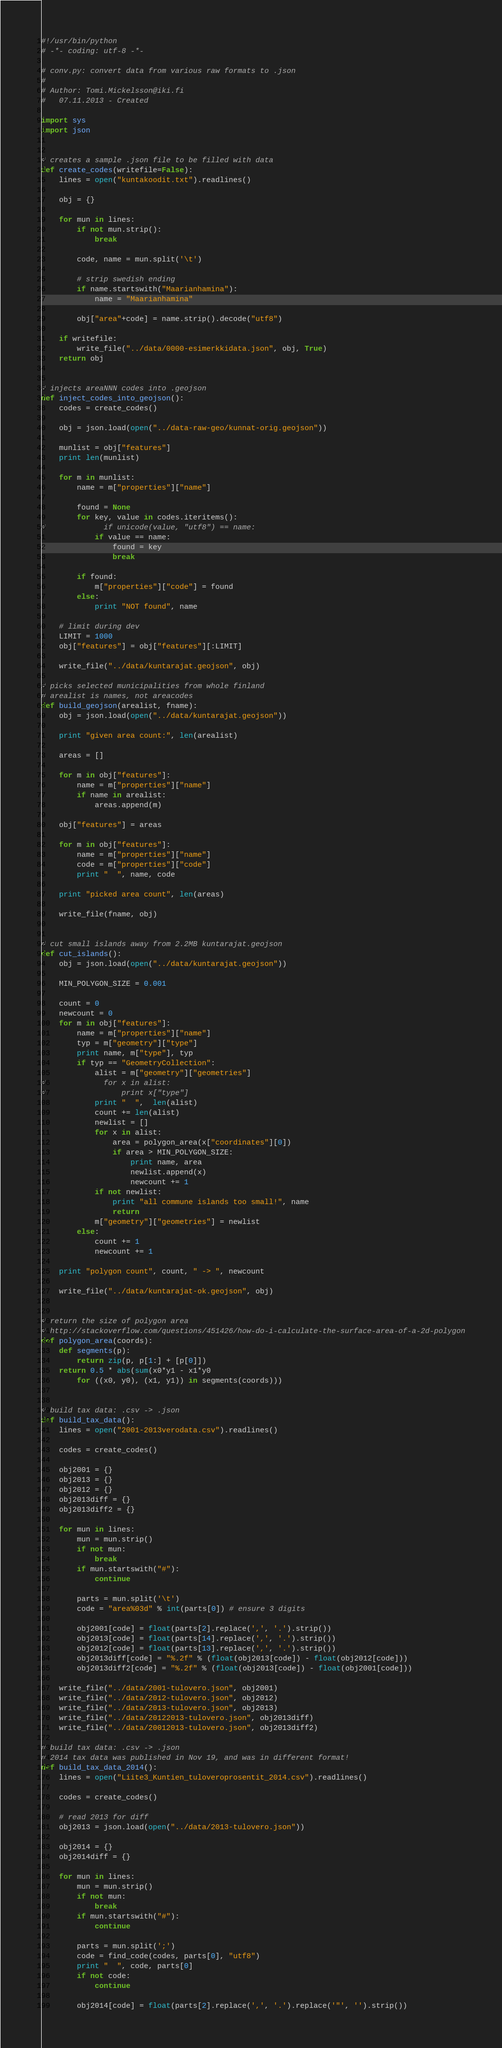Convert code to text. <code><loc_0><loc_0><loc_500><loc_500><_Python_>#!/usr/bin/python
# -*- coding: utf-8 -*-

# conv.py: convert data from various raw formats to .json
#
# Author: Tomi.Mickelsson@iki.fi
#   07.11.2013 - Created

import sys
import json


# creates a sample .json file to be filled with data
def create_codes(writefile=False):
    lines = open("kuntakoodit.txt").readlines()

    obj = {}

    for mun in lines:
        if not mun.strip():
            break

        code, name = mun.split('\t')

        # strip swedish ending
        if name.startswith("Maarianhamina"):
            name = "Maarianhamina"

        obj["area"+code] = name.strip().decode("utf8")

    if writefile:
        write_file("../data/0000-esimerkkidata.json", obj, True)
    return obj


# injects areaNNN codes into .geojson
def inject_codes_into_geojson():
    codes = create_codes()

    obj = json.load(open("../data-raw-geo/kunnat-orig.geojson"))

    munlist = obj["features"]
    print len(munlist)

    for m in munlist:
        name = m["properties"]["name"]

        found = None
        for key, value in codes.iteritems():
#             if unicode(value, "utf8") == name:
            if value == name:
                found = key
                break

        if found:
            m["properties"]["code"] = found
        else:
            print "NOT found", name

    # limit during dev
    LIMIT = 1000
    obj["features"] = obj["features"][:LIMIT]

    write_file("../data/kuntarajat.geojson", obj)

# picks selected municipalities from whole finland
# arealist is names, not areacodes
def build_geojson(arealist, fname):
    obj = json.load(open("../data/kuntarajat.geojson"))

    print "given area count:", len(arealist)

    areas = []

    for m in obj["features"]:
        name = m["properties"]["name"]
        if name in arealist:
            areas.append(m)

    obj["features"] = areas

    for m in obj["features"]:
        name = m["properties"]["name"]
        code = m["properties"]["code"]
        print "  ", name, code

    print "picked area count", len(areas)

    write_file(fname, obj)


# cut small islands away from 2.2MB kuntarajat.geojson
def cut_islands():
    obj = json.load(open("../data/kuntarajat.geojson"))

    MIN_POLYGON_SIZE = 0.001

    count = 0
    newcount = 0
    for m in obj["features"]:
        name = m["properties"]["name"]
        typ = m["geometry"]["type"]
        print name, m["type"], typ
        if typ == "GeometryCollection":
            alist = m["geometry"]["geometries"]
#             for x in alist:
#                 print x["type"]
            print "  ",  len(alist)
            count += len(alist)
            newlist = []
            for x in alist:
                area = polygon_area(x["coordinates"][0])
                if area > MIN_POLYGON_SIZE:
                    print name, area
                    newlist.append(x)
                    newcount += 1
            if not newlist:
                print "all commune islands too small!", name
                return
            m["geometry"]["geometries"] = newlist
        else:
            count += 1
            newcount += 1

    print "polygon count", count, " -> ", newcount

    write_file("../data/kuntarajat-ok.geojson", obj)


# return the size of polygon area
# http://stackoverflow.com/questions/451426/how-do-i-calculate-the-surface-area-of-a-2d-polygon
def polygon_area(coords):
    def segments(p):
        return zip(p, p[1:] + [p[0]])
    return 0.5 * abs(sum(x0*y1 - x1*y0
        for ((x0, y0), (x1, y1)) in segments(coords)))


# build tax data: .csv -> .json
def build_tax_data():
    lines = open("2001-2013verodata.csv").readlines()

    codes = create_codes()

    obj2001 = {}
    obj2013 = {}
    obj2012 = {}
    obj2013diff = {}
    obj2013diff2 = {}

    for mun in lines:
        mun = mun.strip()
        if not mun:
            break
        if mun.startswith("#"):
            continue

        parts = mun.split('\t')
        code = "area%03d" % int(parts[0]) # ensure 3 digits

        obj2001[code] = float(parts[2].replace(',', '.').strip())
        obj2013[code] = float(parts[14].replace(',', '.').strip())
        obj2012[code] = float(parts[13].replace(',', '.').strip())
        obj2013diff[code] = "%.2f" % (float(obj2013[code]) - float(obj2012[code]))
        obj2013diff2[code] = "%.2f" % (float(obj2013[code]) - float(obj2001[code]))

    write_file("../data/2001-tulovero.json", obj2001)
    write_file("../data/2012-tulovero.json", obj2012)
    write_file("../data/2013-tulovero.json", obj2013)
    write_file("../data/20122013-tulovero.json", obj2013diff)
    write_file("../data/20012013-tulovero.json", obj2013diff2)

# build tax data: .csv -> .json
# 2014 tax data was published in Nov 19, and was in different format!
def build_tax_data_2014():
    lines = open("Liite3_Kuntien_tuloveroprosentit_2014.csv").readlines()

    codes = create_codes()

    # read 2013 for diff
    obj2013 = json.load(open("../data/2013-tulovero.json"))

    obj2014 = {}
    obj2014diff = {}

    for mun in lines:
        mun = mun.strip()
        if not mun:
            break
        if mun.startswith("#"):
            continue

        parts = mun.split(';')
        code = find_code(codes, parts[0], "utf8")
        print "  ", code, parts[0]
        if not code:
            continue

        obj2014[code] = float(parts[2].replace(',', '.').replace('"', '').strip())</code> 